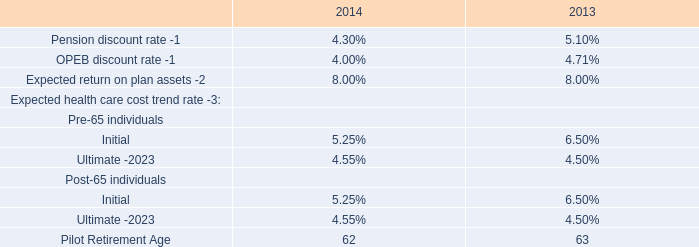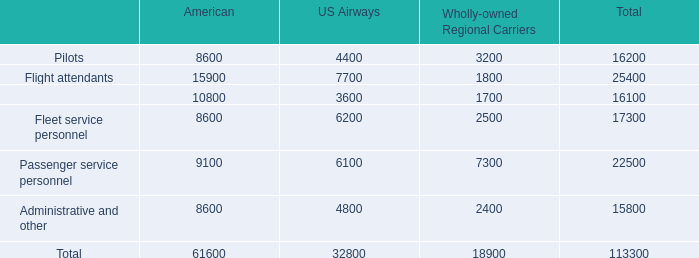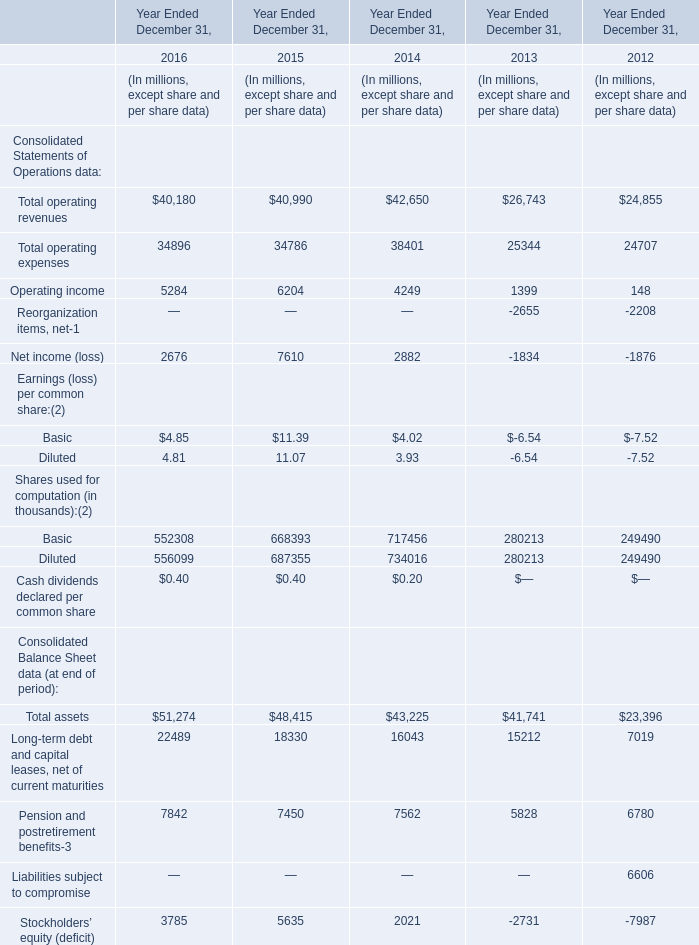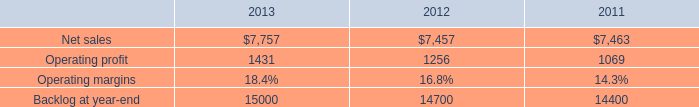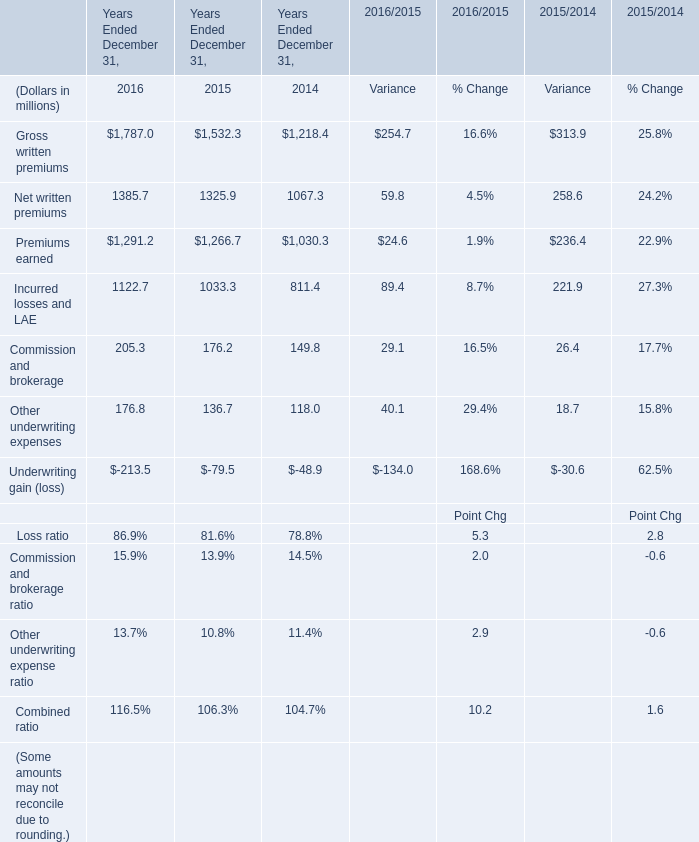What's the average of Incurred losses and LAE of Years Ended December 31, 2015, and Passenger service personnel of American ? 
Computations: ((1033.3 + 9100.0) / 2)
Answer: 5066.65. 